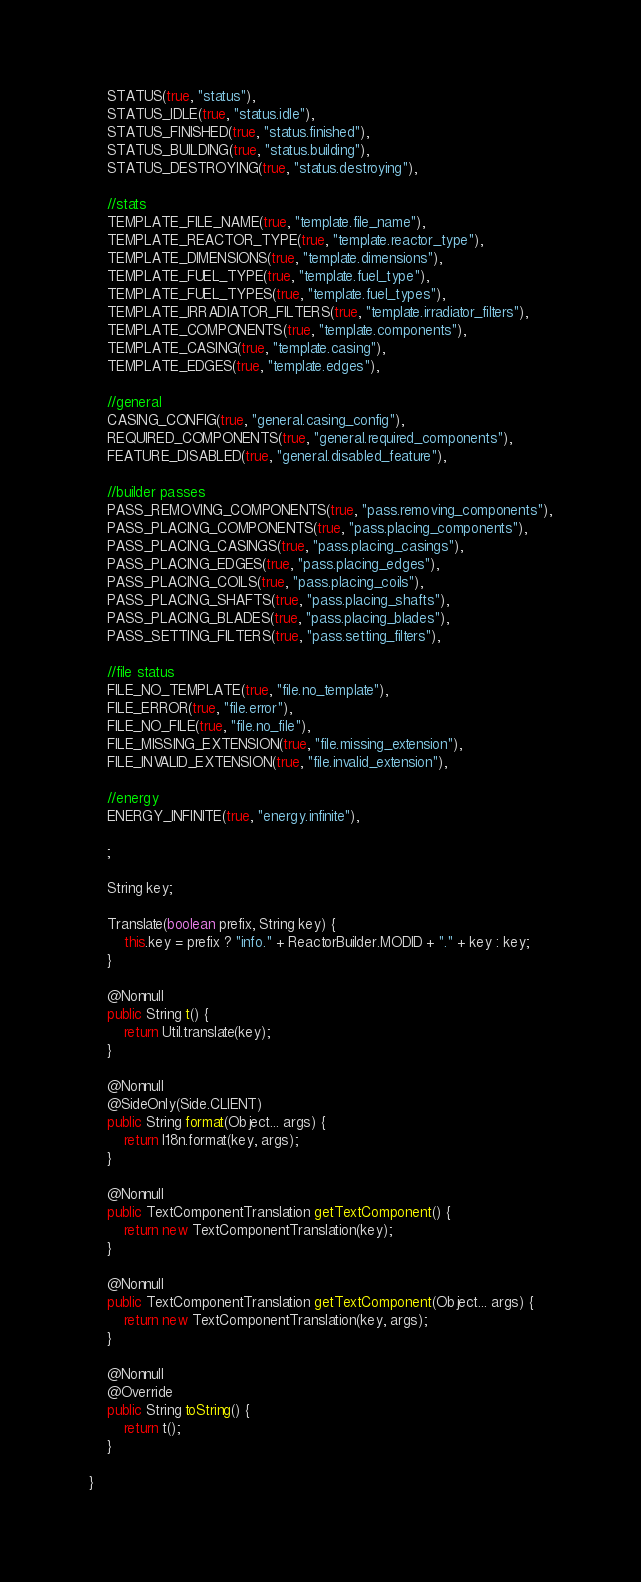<code> <loc_0><loc_0><loc_500><loc_500><_Java_>    STATUS(true, "status"),
    STATUS_IDLE(true, "status.idle"),
    STATUS_FINISHED(true, "status.finished"),
    STATUS_BUILDING(true, "status.building"),
    STATUS_DESTROYING(true, "status.destroying"),

    //stats
    TEMPLATE_FILE_NAME(true, "template.file_name"),
    TEMPLATE_REACTOR_TYPE(true, "template.reactor_type"),
    TEMPLATE_DIMENSIONS(true, "template.dimensions"),
    TEMPLATE_FUEL_TYPE(true, "template.fuel_type"),
    TEMPLATE_FUEL_TYPES(true, "template.fuel_types"),
    TEMPLATE_IRRADIATOR_FILTERS(true, "template.irradiator_filters"),
    TEMPLATE_COMPONENTS(true, "template.components"),
    TEMPLATE_CASING(true, "template.casing"),
    TEMPLATE_EDGES(true, "template.edges"),

    //general
    CASING_CONFIG(true, "general.casing_config"),
    REQUIRED_COMPONENTS(true, "general.required_components"),
    FEATURE_DISABLED(true, "general.disabled_feature"),

    //builder passes
    PASS_REMOVING_COMPONENTS(true, "pass.removing_components"),
    PASS_PLACING_COMPONENTS(true, "pass.placing_components"),
    PASS_PLACING_CASINGS(true, "pass.placing_casings"),
    PASS_PLACING_EDGES(true, "pass.placing_edges"),
    PASS_PLACING_COILS(true, "pass.placing_coils"),
    PASS_PLACING_SHAFTS(true, "pass.placing_shafts"),
    PASS_PLACING_BLADES(true, "pass.placing_blades"),
    PASS_SETTING_FILTERS(true, "pass.setting_filters"),

    //file status
    FILE_NO_TEMPLATE(true, "file.no_template"),
    FILE_ERROR(true, "file.error"),
    FILE_NO_FILE(true, "file.no_file"),
    FILE_MISSING_EXTENSION(true, "file.missing_extension"),
    FILE_INVALID_EXTENSION(true, "file.invalid_extension"),

    //energy
    ENERGY_INFINITE(true, "energy.infinite"),

    ;

    String key;

    Translate(boolean prefix, String key) {
        this.key = prefix ? "info." + ReactorBuilder.MODID + "." + key : key;
    }

    @Nonnull
    public String t() {
        return Util.translate(key);
    }

    @Nonnull
    @SideOnly(Side.CLIENT)
    public String format(Object... args) {
        return I18n.format(key, args);
    }

    @Nonnull
    public TextComponentTranslation getTextComponent() {
        return new TextComponentTranslation(key);
    }

    @Nonnull
    public TextComponentTranslation getTextComponent(Object... args) {
        return new TextComponentTranslation(key, args);
    }

    @Nonnull
    @Override
    public String toString() {
        return t();
    }

}
</code> 